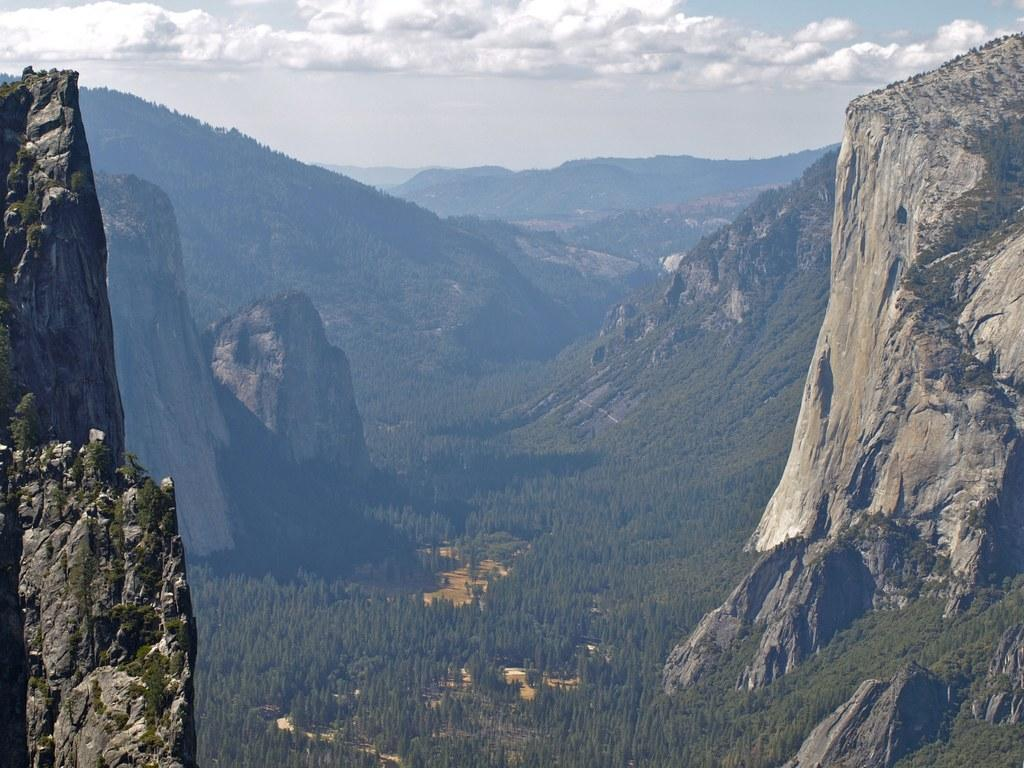What type of natural features can be seen in the image? There are rocks, hills, and trees in the image. What is visible at the top of the image? The sky is visible at the top of the image. What is the condition of the sky in the image? The sky is cloudy in the image. What type of smile can be seen on the rocks in the image? There are no smiles present in the image, as rocks are inanimate objects and do not have facial expressions. 